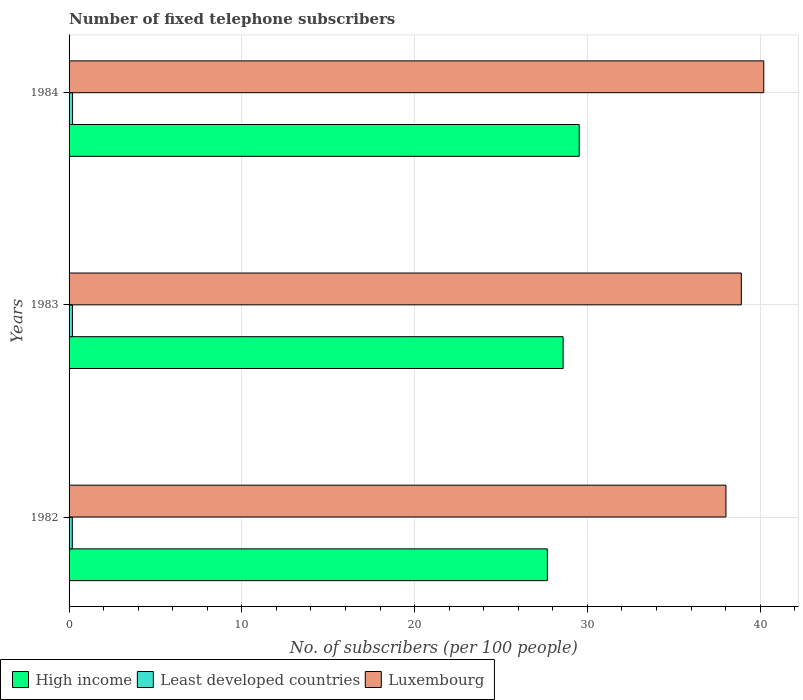How many different coloured bars are there?
Give a very brief answer. 3. How many groups of bars are there?
Make the answer very short. 3. How many bars are there on the 1st tick from the top?
Make the answer very short. 3. How many bars are there on the 2nd tick from the bottom?
Provide a succinct answer. 3. In how many cases, is the number of bars for a given year not equal to the number of legend labels?
Provide a succinct answer. 0. What is the number of fixed telephone subscribers in Least developed countries in 1982?
Offer a very short reply. 0.19. Across all years, what is the maximum number of fixed telephone subscribers in Least developed countries?
Offer a very short reply. 0.2. Across all years, what is the minimum number of fixed telephone subscribers in Luxembourg?
Make the answer very short. 38.02. In which year was the number of fixed telephone subscribers in Luxembourg minimum?
Keep it short and to the point. 1982. What is the total number of fixed telephone subscribers in Luxembourg in the graph?
Make the answer very short. 117.13. What is the difference between the number of fixed telephone subscribers in High income in 1982 and that in 1984?
Your response must be concise. -1.84. What is the difference between the number of fixed telephone subscribers in High income in 1983 and the number of fixed telephone subscribers in Least developed countries in 1982?
Provide a succinct answer. 28.41. What is the average number of fixed telephone subscribers in High income per year?
Provide a succinct answer. 28.6. In the year 1982, what is the difference between the number of fixed telephone subscribers in Least developed countries and number of fixed telephone subscribers in High income?
Offer a very short reply. -27.49. What is the ratio of the number of fixed telephone subscribers in Least developed countries in 1982 to that in 1984?
Make the answer very short. 0.93. Is the number of fixed telephone subscribers in Least developed countries in 1982 less than that in 1984?
Make the answer very short. Yes. What is the difference between the highest and the second highest number of fixed telephone subscribers in Luxembourg?
Make the answer very short. 1.3. What is the difference between the highest and the lowest number of fixed telephone subscribers in Least developed countries?
Your response must be concise. 0.02. Is the sum of the number of fixed telephone subscribers in Luxembourg in 1983 and 1984 greater than the maximum number of fixed telephone subscribers in High income across all years?
Offer a terse response. Yes. What does the 1st bar from the top in 1983 represents?
Give a very brief answer. Luxembourg. What does the 2nd bar from the bottom in 1984 represents?
Keep it short and to the point. Least developed countries. Is it the case that in every year, the sum of the number of fixed telephone subscribers in Least developed countries and number of fixed telephone subscribers in Luxembourg is greater than the number of fixed telephone subscribers in High income?
Give a very brief answer. Yes. What is the difference between two consecutive major ticks on the X-axis?
Keep it short and to the point. 10. Are the values on the major ticks of X-axis written in scientific E-notation?
Offer a very short reply. No. Does the graph contain grids?
Give a very brief answer. Yes. Where does the legend appear in the graph?
Provide a succinct answer. Bottom left. How are the legend labels stacked?
Provide a succinct answer. Horizontal. What is the title of the graph?
Your answer should be compact. Number of fixed telephone subscribers. What is the label or title of the X-axis?
Provide a succinct answer. No. of subscribers (per 100 people). What is the No. of subscribers (per 100 people) of High income in 1982?
Provide a short and direct response. 27.68. What is the No. of subscribers (per 100 people) of Least developed countries in 1982?
Ensure brevity in your answer.  0.19. What is the No. of subscribers (per 100 people) of Luxembourg in 1982?
Your answer should be compact. 38.02. What is the No. of subscribers (per 100 people) in High income in 1983?
Keep it short and to the point. 28.59. What is the No. of subscribers (per 100 people) of Least developed countries in 1983?
Ensure brevity in your answer.  0.2. What is the No. of subscribers (per 100 people) in Luxembourg in 1983?
Provide a succinct answer. 38.91. What is the No. of subscribers (per 100 people) of High income in 1984?
Provide a short and direct response. 29.52. What is the No. of subscribers (per 100 people) in Least developed countries in 1984?
Provide a short and direct response. 0.2. What is the No. of subscribers (per 100 people) in Luxembourg in 1984?
Make the answer very short. 40.21. Across all years, what is the maximum No. of subscribers (per 100 people) of High income?
Ensure brevity in your answer.  29.52. Across all years, what is the maximum No. of subscribers (per 100 people) in Least developed countries?
Your answer should be compact. 0.2. Across all years, what is the maximum No. of subscribers (per 100 people) of Luxembourg?
Offer a very short reply. 40.21. Across all years, what is the minimum No. of subscribers (per 100 people) of High income?
Offer a terse response. 27.68. Across all years, what is the minimum No. of subscribers (per 100 people) of Least developed countries?
Ensure brevity in your answer.  0.19. Across all years, what is the minimum No. of subscribers (per 100 people) of Luxembourg?
Keep it short and to the point. 38.02. What is the total No. of subscribers (per 100 people) of High income in the graph?
Keep it short and to the point. 85.8. What is the total No. of subscribers (per 100 people) of Least developed countries in the graph?
Offer a very short reply. 0.59. What is the total No. of subscribers (per 100 people) in Luxembourg in the graph?
Give a very brief answer. 117.13. What is the difference between the No. of subscribers (per 100 people) of High income in 1982 and that in 1983?
Keep it short and to the point. -0.91. What is the difference between the No. of subscribers (per 100 people) in Least developed countries in 1982 and that in 1983?
Offer a very short reply. -0.01. What is the difference between the No. of subscribers (per 100 people) of Luxembourg in 1982 and that in 1983?
Offer a terse response. -0.89. What is the difference between the No. of subscribers (per 100 people) in High income in 1982 and that in 1984?
Ensure brevity in your answer.  -1.84. What is the difference between the No. of subscribers (per 100 people) of Least developed countries in 1982 and that in 1984?
Ensure brevity in your answer.  -0.02. What is the difference between the No. of subscribers (per 100 people) in Luxembourg in 1982 and that in 1984?
Keep it short and to the point. -2.19. What is the difference between the No. of subscribers (per 100 people) in High income in 1983 and that in 1984?
Keep it short and to the point. -0.93. What is the difference between the No. of subscribers (per 100 people) in Least developed countries in 1983 and that in 1984?
Provide a short and direct response. -0.01. What is the difference between the No. of subscribers (per 100 people) of Luxembourg in 1983 and that in 1984?
Your answer should be compact. -1.3. What is the difference between the No. of subscribers (per 100 people) in High income in 1982 and the No. of subscribers (per 100 people) in Least developed countries in 1983?
Your answer should be very brief. 27.49. What is the difference between the No. of subscribers (per 100 people) of High income in 1982 and the No. of subscribers (per 100 people) of Luxembourg in 1983?
Give a very brief answer. -11.23. What is the difference between the No. of subscribers (per 100 people) in Least developed countries in 1982 and the No. of subscribers (per 100 people) in Luxembourg in 1983?
Keep it short and to the point. -38.72. What is the difference between the No. of subscribers (per 100 people) of High income in 1982 and the No. of subscribers (per 100 people) of Least developed countries in 1984?
Your answer should be very brief. 27.48. What is the difference between the No. of subscribers (per 100 people) in High income in 1982 and the No. of subscribers (per 100 people) in Luxembourg in 1984?
Provide a short and direct response. -12.52. What is the difference between the No. of subscribers (per 100 people) of Least developed countries in 1982 and the No. of subscribers (per 100 people) of Luxembourg in 1984?
Offer a terse response. -40.02. What is the difference between the No. of subscribers (per 100 people) of High income in 1983 and the No. of subscribers (per 100 people) of Least developed countries in 1984?
Provide a succinct answer. 28.39. What is the difference between the No. of subscribers (per 100 people) in High income in 1983 and the No. of subscribers (per 100 people) in Luxembourg in 1984?
Your answer should be compact. -11.61. What is the difference between the No. of subscribers (per 100 people) in Least developed countries in 1983 and the No. of subscribers (per 100 people) in Luxembourg in 1984?
Provide a short and direct response. -40.01. What is the average No. of subscribers (per 100 people) in High income per year?
Offer a terse response. 28.6. What is the average No. of subscribers (per 100 people) of Least developed countries per year?
Offer a very short reply. 0.2. What is the average No. of subscribers (per 100 people) of Luxembourg per year?
Offer a terse response. 39.04. In the year 1982, what is the difference between the No. of subscribers (per 100 people) of High income and No. of subscribers (per 100 people) of Least developed countries?
Your answer should be compact. 27.49. In the year 1982, what is the difference between the No. of subscribers (per 100 people) in High income and No. of subscribers (per 100 people) in Luxembourg?
Make the answer very short. -10.34. In the year 1982, what is the difference between the No. of subscribers (per 100 people) of Least developed countries and No. of subscribers (per 100 people) of Luxembourg?
Your answer should be very brief. -37.83. In the year 1983, what is the difference between the No. of subscribers (per 100 people) in High income and No. of subscribers (per 100 people) in Least developed countries?
Ensure brevity in your answer.  28.4. In the year 1983, what is the difference between the No. of subscribers (per 100 people) of High income and No. of subscribers (per 100 people) of Luxembourg?
Offer a very short reply. -10.31. In the year 1983, what is the difference between the No. of subscribers (per 100 people) of Least developed countries and No. of subscribers (per 100 people) of Luxembourg?
Your answer should be compact. -38.71. In the year 1984, what is the difference between the No. of subscribers (per 100 people) in High income and No. of subscribers (per 100 people) in Least developed countries?
Make the answer very short. 29.32. In the year 1984, what is the difference between the No. of subscribers (per 100 people) in High income and No. of subscribers (per 100 people) in Luxembourg?
Your answer should be compact. -10.68. In the year 1984, what is the difference between the No. of subscribers (per 100 people) in Least developed countries and No. of subscribers (per 100 people) in Luxembourg?
Ensure brevity in your answer.  -40. What is the ratio of the No. of subscribers (per 100 people) in High income in 1982 to that in 1983?
Provide a short and direct response. 0.97. What is the ratio of the No. of subscribers (per 100 people) of Least developed countries in 1982 to that in 1983?
Keep it short and to the point. 0.96. What is the ratio of the No. of subscribers (per 100 people) of Luxembourg in 1982 to that in 1983?
Offer a terse response. 0.98. What is the ratio of the No. of subscribers (per 100 people) in High income in 1982 to that in 1984?
Make the answer very short. 0.94. What is the ratio of the No. of subscribers (per 100 people) of Least developed countries in 1982 to that in 1984?
Provide a short and direct response. 0.93. What is the ratio of the No. of subscribers (per 100 people) of Luxembourg in 1982 to that in 1984?
Offer a very short reply. 0.95. What is the ratio of the No. of subscribers (per 100 people) in High income in 1983 to that in 1984?
Your response must be concise. 0.97. What is the ratio of the No. of subscribers (per 100 people) of Least developed countries in 1983 to that in 1984?
Ensure brevity in your answer.  0.96. What is the difference between the highest and the second highest No. of subscribers (per 100 people) in Least developed countries?
Your answer should be compact. 0.01. What is the difference between the highest and the second highest No. of subscribers (per 100 people) of Luxembourg?
Offer a terse response. 1.3. What is the difference between the highest and the lowest No. of subscribers (per 100 people) of High income?
Make the answer very short. 1.84. What is the difference between the highest and the lowest No. of subscribers (per 100 people) of Least developed countries?
Make the answer very short. 0.02. What is the difference between the highest and the lowest No. of subscribers (per 100 people) of Luxembourg?
Provide a short and direct response. 2.19. 